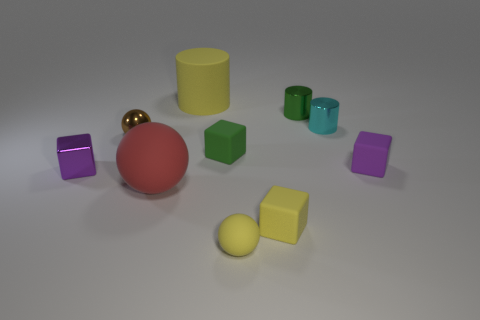Subtract all cyan cubes. Subtract all yellow spheres. How many cubes are left? 4 Subtract all balls. How many objects are left? 7 Add 2 tiny metallic things. How many tiny metallic things are left? 6 Add 7 tiny purple objects. How many tiny purple objects exist? 9 Subtract 1 brown balls. How many objects are left? 9 Subtract all small matte objects. Subtract all blue things. How many objects are left? 6 